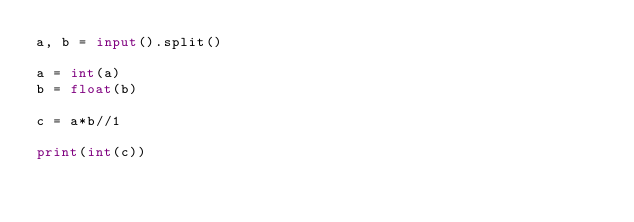<code> <loc_0><loc_0><loc_500><loc_500><_Python_>a, b = input().split()

a = int(a)
b = float(b)

c = a*b//1

print(int(c))</code> 